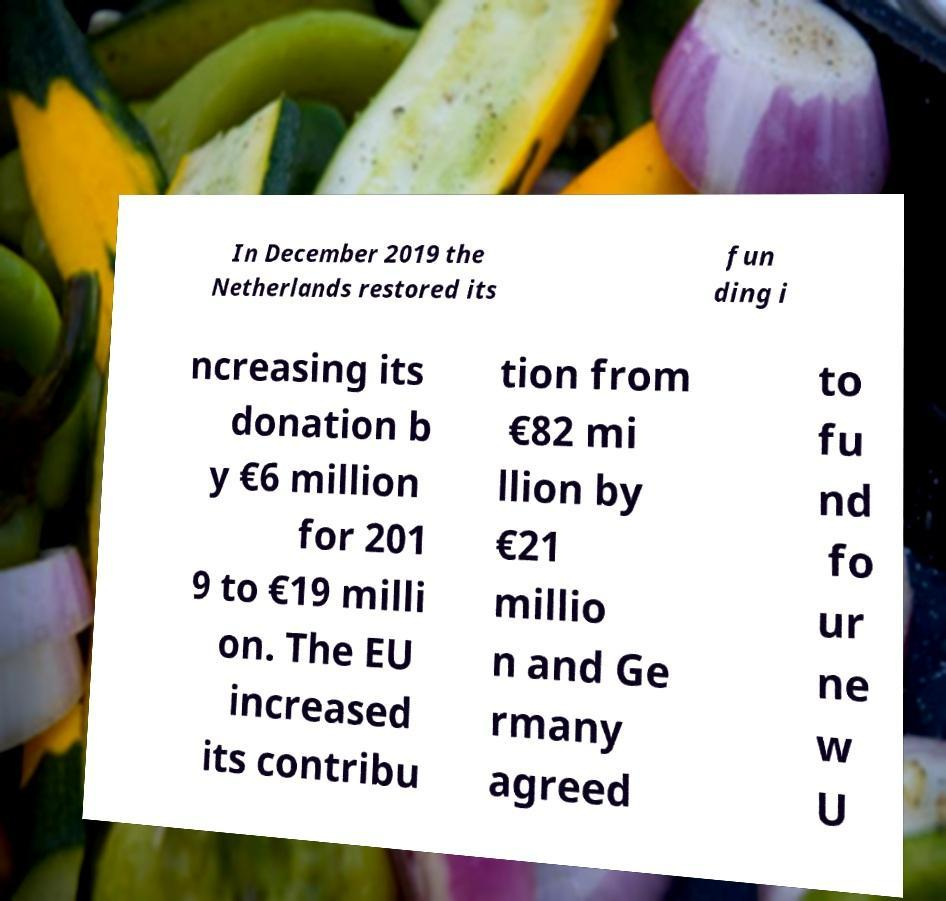Could you extract and type out the text from this image? In December 2019 the Netherlands restored its fun ding i ncreasing its donation b y €6 million for 201 9 to €19 milli on. The EU increased its contribu tion from €82 mi llion by €21 millio n and Ge rmany agreed to fu nd fo ur ne w U 